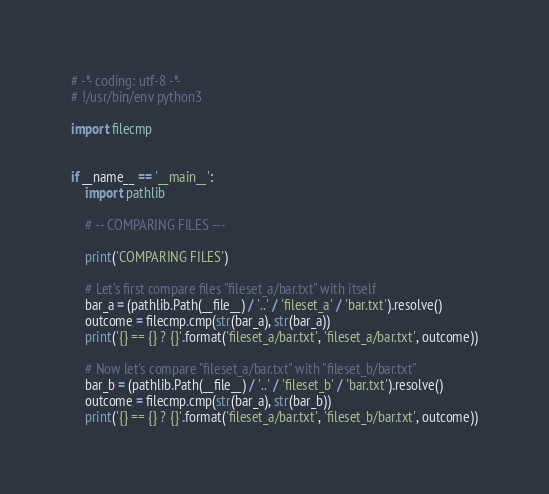Convert code to text. <code><loc_0><loc_0><loc_500><loc_500><_Python_># -*- coding: utf-8 -*-
# !/usr/bin/env python3

import filecmp


if __name__ == '__main__':
    import pathlib

    # -- COMPARING FILES ---

    print('COMPARING FILES')

    # Let's first compare files "fileset_a/bar.txt" with itself
    bar_a = (pathlib.Path(__file__) / '..' / 'fileset_a' / 'bar.txt').resolve()
    outcome = filecmp.cmp(str(bar_a), str(bar_a))
    print('{} == {} ? {}'.format('fileset_a/bar.txt', 'fileset_a/bar.txt', outcome))

    # Now let's compare "fileset_a/bar.txt" with "fileset_b/bar.txt"
    bar_b = (pathlib.Path(__file__) / '..' / 'fileset_b' / 'bar.txt').resolve()
    outcome = filecmp.cmp(str(bar_a), str(bar_b))
    print('{} == {} ? {}'.format('fileset_a/bar.txt', 'fileset_b/bar.txt', outcome))

</code> 